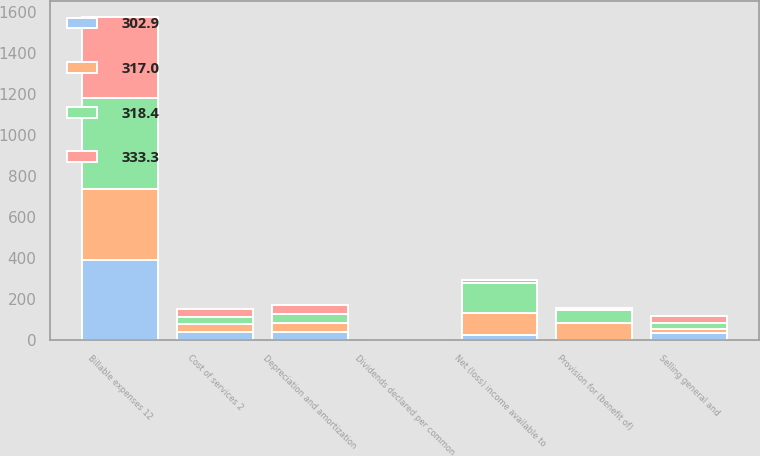Convert chart to OTSL. <chart><loc_0><loc_0><loc_500><loc_500><stacked_bar_chart><ecel><fcel>Billable expenses 12<fcel>Cost of services 2<fcel>Selling general and<fcel>Depreciation and amortization<fcel>Provision for (benefit of)<fcel>Net (loss) income available to<fcel>Dividends declared per common<nl><fcel>333.3<fcel>395.1<fcel>38.1<fcel>35.1<fcel>46<fcel>12.7<fcel>14.1<fcel>0.21<nl><fcel>302.9<fcel>388.5<fcel>38.1<fcel>35.2<fcel>41<fcel>0.3<fcel>24.7<fcel>0.18<nl><fcel>318.4<fcel>443.6<fcel>38.1<fcel>28.8<fcel>44<fcel>63.6<fcel>145.8<fcel>0.21<nl><fcel>317<fcel>351.2<fcel>38.1<fcel>20.3<fcel>41.3<fcel>81.6<fcel>107.7<fcel>0.18<nl></chart> 